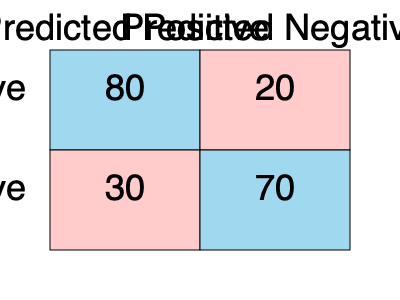Given the confusion matrix above for a binary classification model, calculate the model's accuracy and identify a potential bias that might be present in the model's predictions. How might this bias impact the model's performance in a real-world scenario? To answer this question, we'll follow these steps:

1. Calculate the model's accuracy:
   Accuracy = (True Positives + True Negatives) / Total Predictions
   $$ \text{Accuracy} = \frac{80 + 70}{80 + 20 + 30 + 70} = \frac{150}{200} = 0.75 \text{ or } 75\% $$

2. Identify potential bias:
   - True Positives (TP) = 80
   - False Positives (FP) = 30
   - False Negatives (FN) = 20
   - True Negatives (TN) = 70

   The model seems to have a higher tendency to predict positive results:
   $$ \text{Positive Predictions} = 80 + 30 = 110 $$
   $$ \text{Negative Predictions} = 20 + 70 = 90 $$

   This suggests a potential bias towards positive predictions.

3. Calculate precision and recall:
   $$ \text{Precision} = \frac{TP}{TP + FP} = \frac{80}{80 + 30} \approx 0.73 $$
   $$ \text{Recall} = \frac{TP}{TP + FN} = \frac{80}{80 + 20} = 0.80 $$

   The model has higher recall than precision, further indicating a bias towards positive predictions.

4. Impact in a real-world scenario:
   - This bias could lead to more false positives, which might be problematic in certain applications (e.g., medical diagnoses, fraud detection).
   - The model might overlook some negative cases, potentially missing important instances that require attention.
   - In scenarios where false positives are less costly than false negatives, this bias might be acceptable or even desirable.

The bias towards positive predictions could be due to various factors, such as imbalanced training data, model architecture, or the choice of threshold for binary classification. As a software developer, it's crucial to be aware of such biases and their potential impacts when deploying machine learning models in production environments.
Answer: 75% accuracy; bias towards positive predictions; potential for increased false positives in real-world applications. 